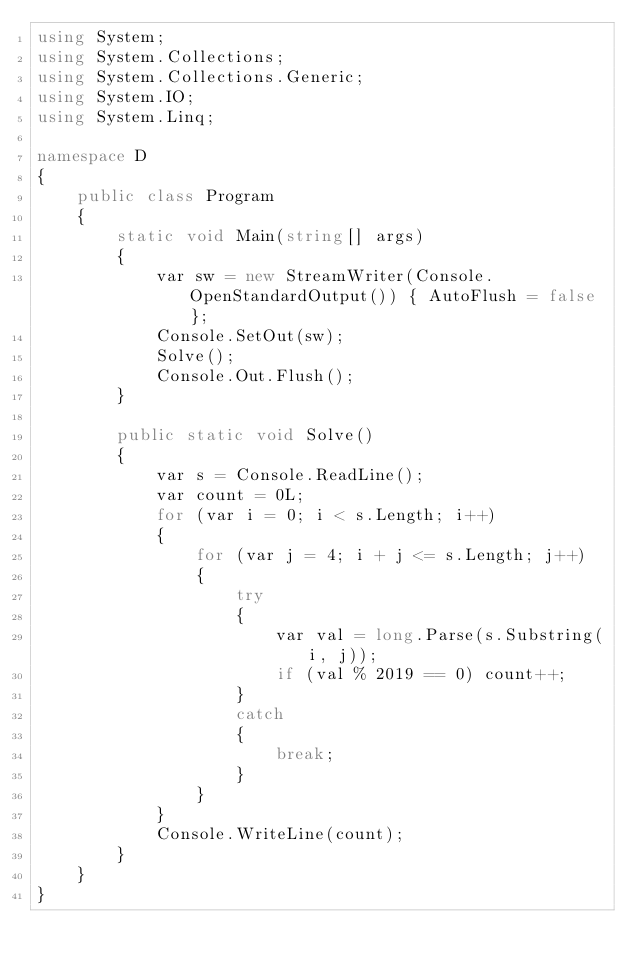Convert code to text. <code><loc_0><loc_0><loc_500><loc_500><_C#_>using System;
using System.Collections;
using System.Collections.Generic;
using System.IO;
using System.Linq;

namespace D
{
    public class Program
    {
        static void Main(string[] args)
        {
            var sw = new StreamWriter(Console.OpenStandardOutput()) { AutoFlush = false };
            Console.SetOut(sw);
            Solve();
            Console.Out.Flush();
        }

        public static void Solve()
        {
            var s = Console.ReadLine();
            var count = 0L;
            for (var i = 0; i < s.Length; i++)
            {
                for (var j = 4; i + j <= s.Length; j++)
                {
                    try
                    {
                        var val = long.Parse(s.Substring(i, j));
                        if (val % 2019 == 0) count++;
                    }
                    catch
                    {
                        break;
                    }
                }
            }
            Console.WriteLine(count);
        }
    }
}
</code> 